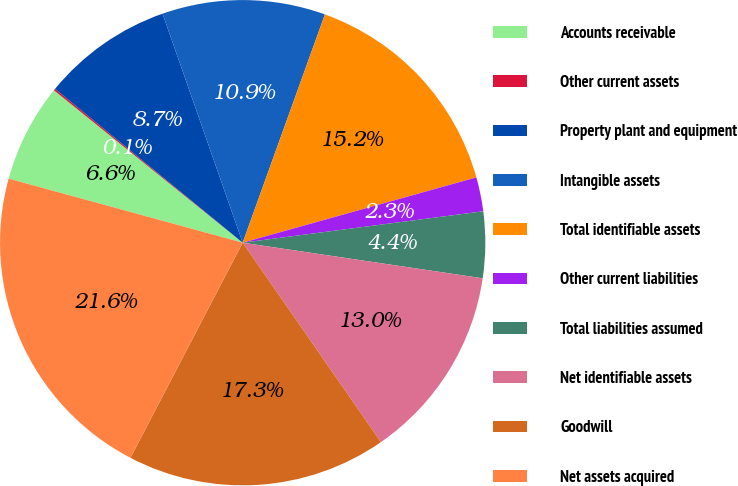Convert chart. <chart><loc_0><loc_0><loc_500><loc_500><pie_chart><fcel>Accounts receivable<fcel>Other current assets<fcel>Property plant and equipment<fcel>Intangible assets<fcel>Total identifiable assets<fcel>Other current liabilities<fcel>Total liabilities assumed<fcel>Net identifiable assets<fcel>Goodwill<fcel>Net assets acquired<nl><fcel>6.56%<fcel>0.12%<fcel>8.71%<fcel>10.86%<fcel>15.16%<fcel>2.27%<fcel>4.41%<fcel>13.01%<fcel>17.3%<fcel>21.6%<nl></chart> 